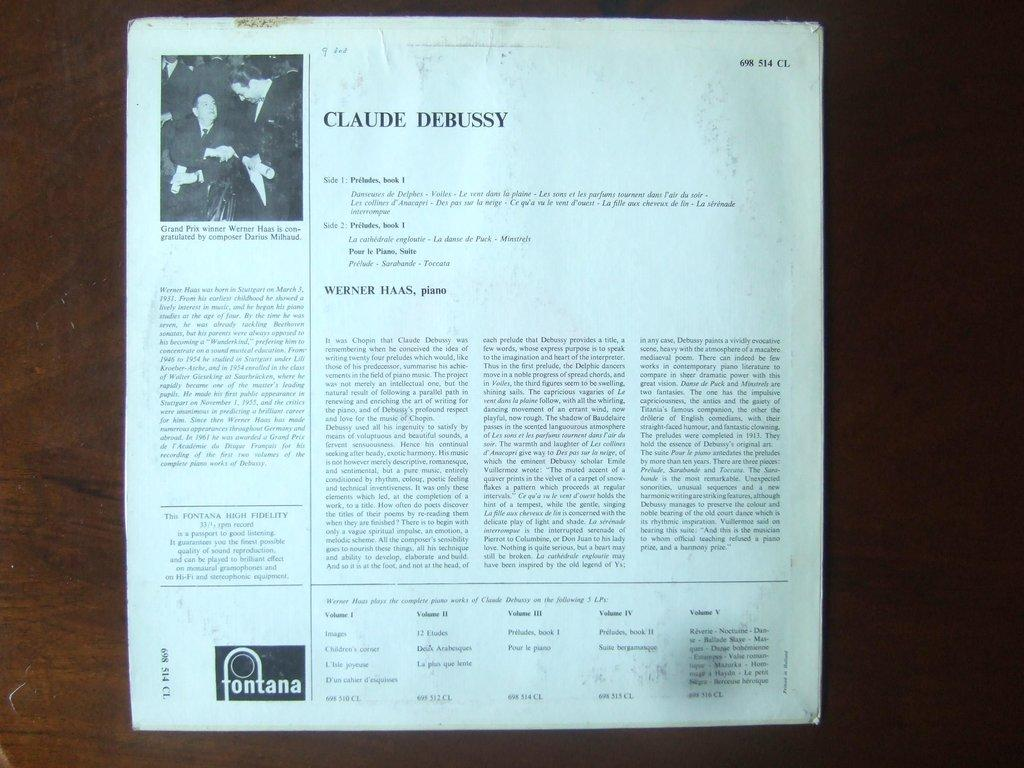<image>
Present a compact description of the photo's key features. a white paper with the name Claude Debussy at the top 